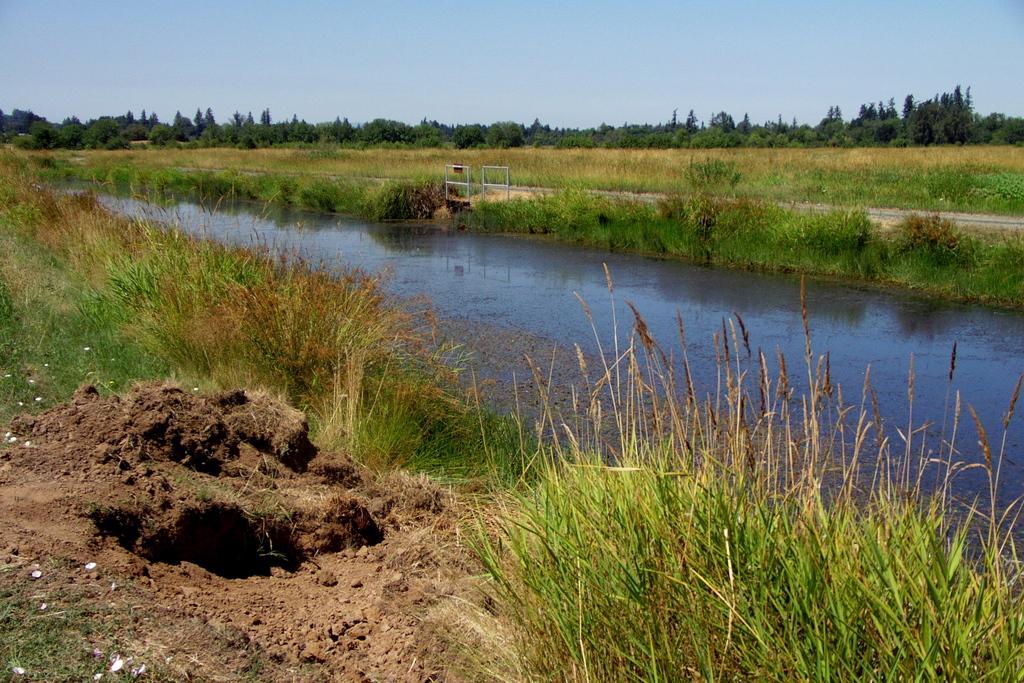Can you describe this image briefly? Here we can see water and to either side of the water there is a grass on the water. In the background we can see path, poles, trees and the sky. 